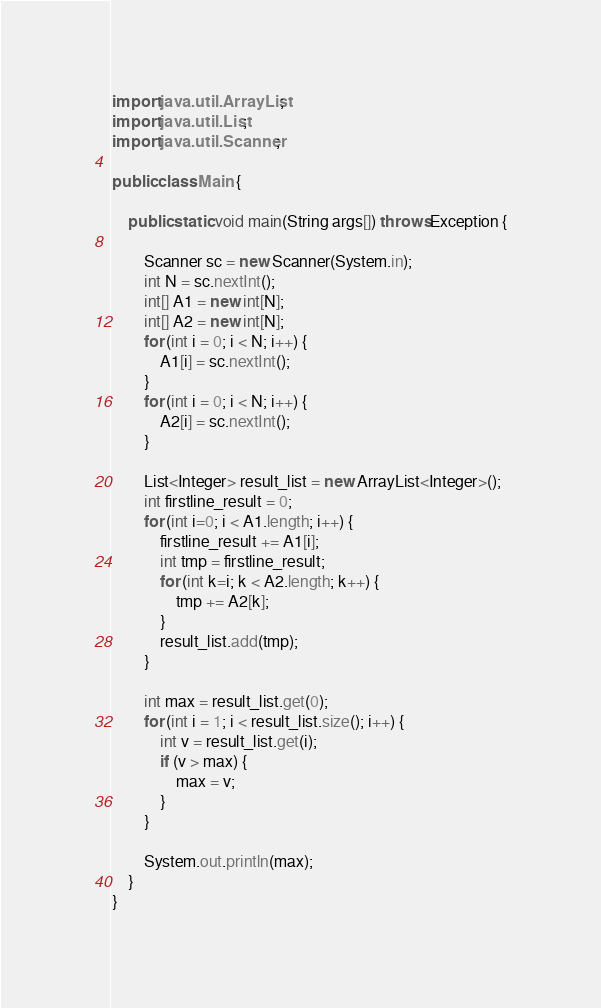<code> <loc_0><loc_0><loc_500><loc_500><_Java_>import java.util.ArrayList;
import java.util.List;
import java.util.Scanner;

public class Main {

    public static void main(String args[]) throws Exception {

        Scanner sc = new Scanner(System.in);
        int N = sc.nextInt();
        int[] A1 = new int[N];
        int[] A2 = new int[N];
        for (int i = 0; i < N; i++) {
            A1[i] = sc.nextInt();
        }
        for (int i = 0; i < N; i++) {
            A2[i] = sc.nextInt();
        }

        List<Integer> result_list = new ArrayList<Integer>();
        int firstline_result = 0;
        for (int i=0; i < A1.length; i++) {
            firstline_result += A1[i];
            int tmp = firstline_result;
            for (int k=i; k < A2.length; k++) {
                tmp += A2[k];
            }
            result_list.add(tmp);
        }

        int max = result_list.get(0);
        for (int i = 1; i < result_list.size(); i++) {
            int v = result_list.get(i);
            if (v > max) {
                max = v;
            }
        }

        System.out.println(max);
    }
}
</code> 